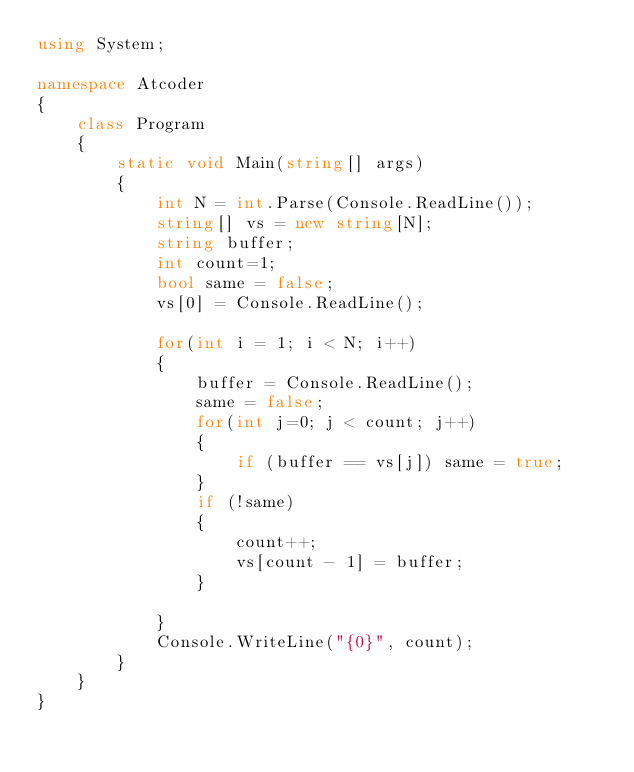Convert code to text. <code><loc_0><loc_0><loc_500><loc_500><_C#_>using System;

namespace Atcoder
{
    class Program
    {
        static void Main(string[] args)
        {
            int N = int.Parse(Console.ReadLine());
            string[] vs = new string[N];
            string buffer;
            int count=1;
            bool same = false;
            vs[0] = Console.ReadLine();

            for(int i = 1; i < N; i++)
            {
                buffer = Console.ReadLine();
                same = false;
                for(int j=0; j < count; j++)
                {
                    if (buffer == vs[j]) same = true;
                }
                if (!same)
                {
                    count++;
                    vs[count - 1] = buffer;
                }

            }
            Console.WriteLine("{0}", count);
        }
    }
}
</code> 